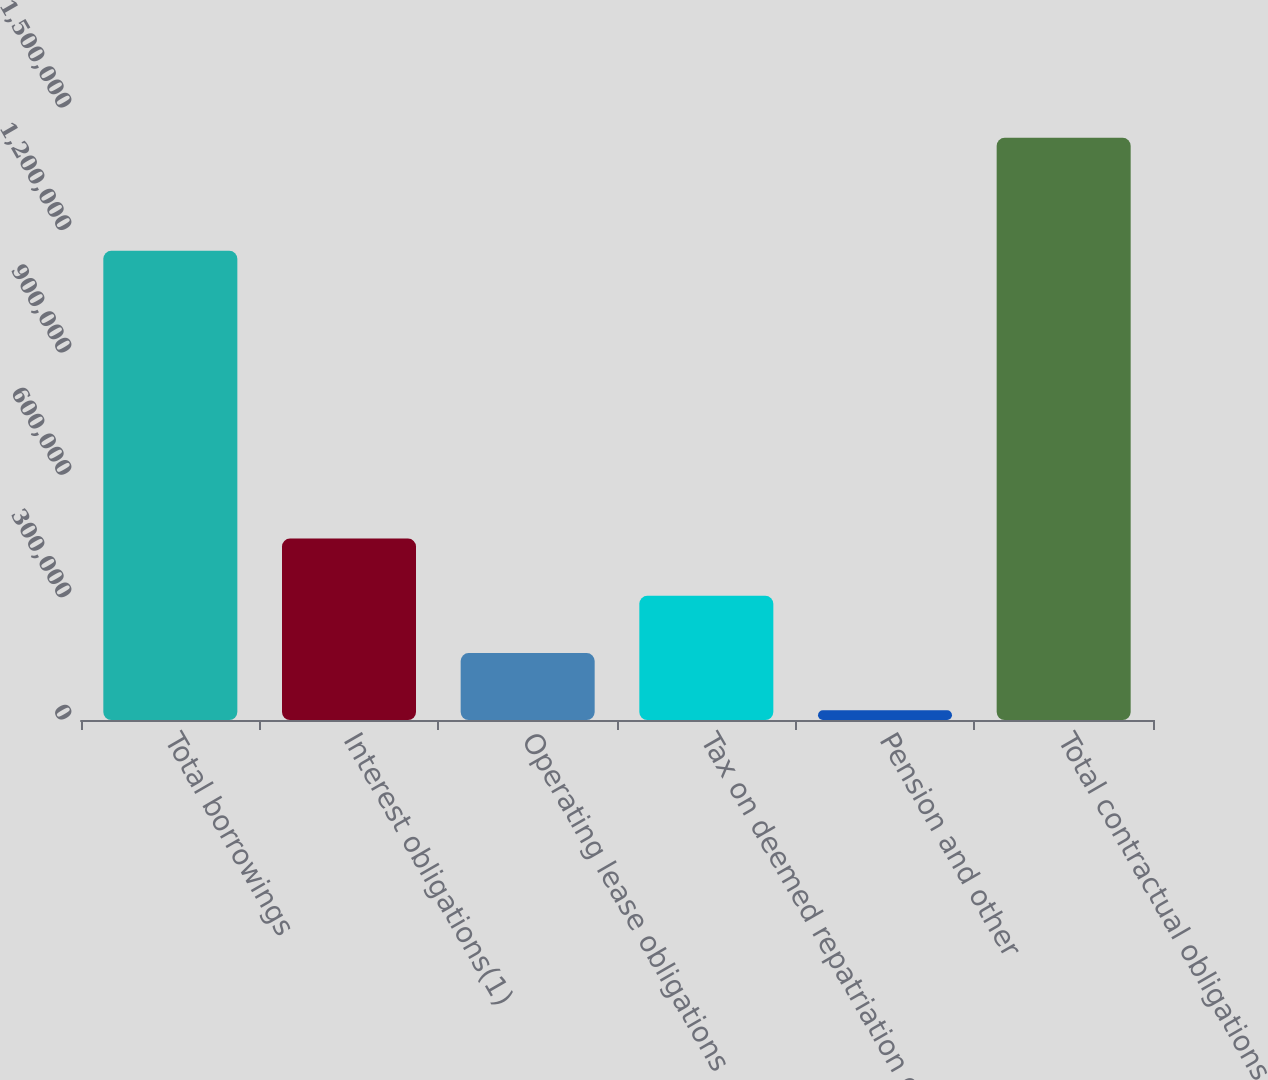Convert chart. <chart><loc_0><loc_0><loc_500><loc_500><bar_chart><fcel>Total borrowings<fcel>Interest obligations(1)<fcel>Operating lease obligations<fcel>Tax on deemed repatriation of<fcel>Pension and other<fcel>Total contractual obligations<nl><fcel>1.15e+06<fcel>444769<fcel>164137<fcel>304453<fcel>23821<fcel>1.42698e+06<nl></chart> 